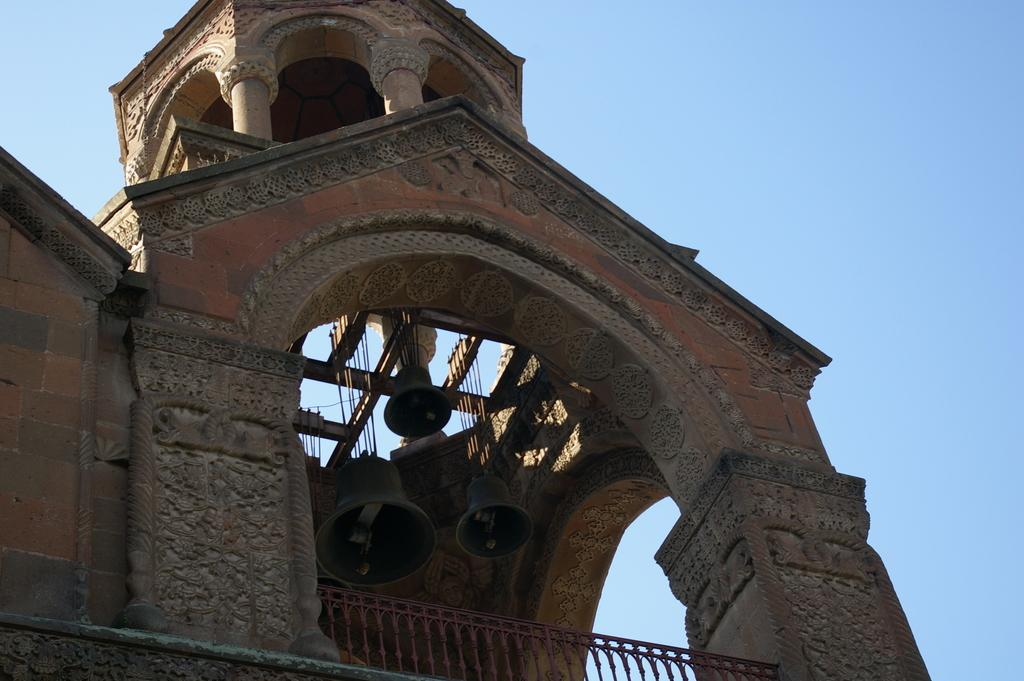What type of structure is visible in the image? There is a building in the image. What material are the rods in the image made of? The rods in the image are made of metal. What objects can be heard making noise in the image? Bells are present in the image. How many divisions are there in the head of the person in the image? There is no person present in the image, so it is not possible to determine the number of divisions in their head. 